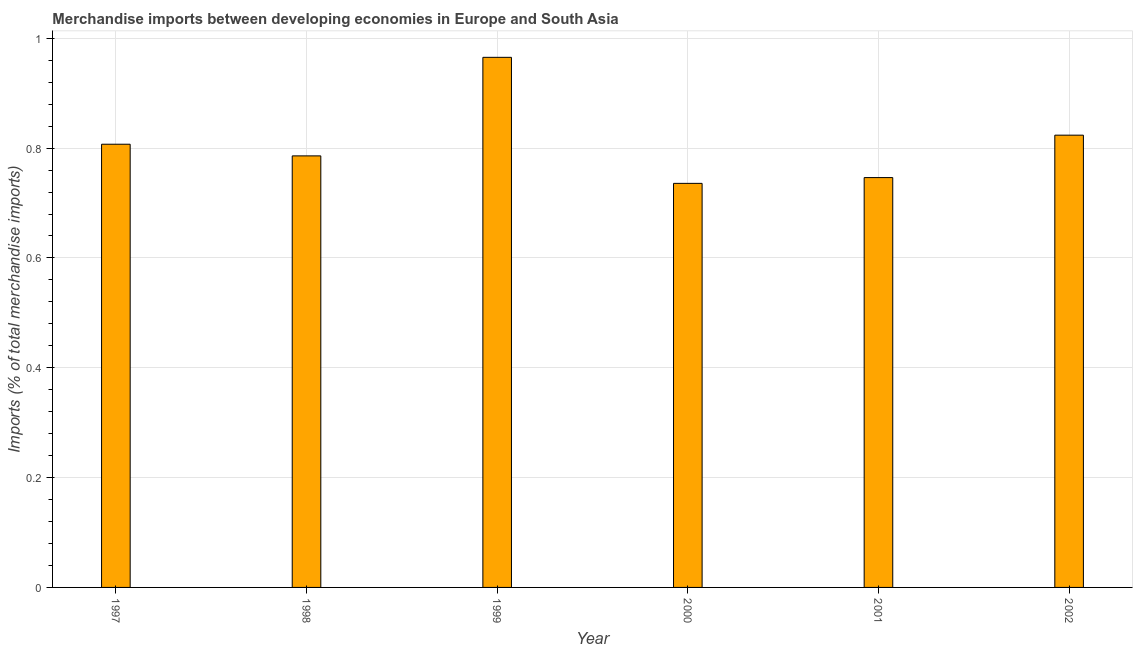Does the graph contain grids?
Your response must be concise. Yes. What is the title of the graph?
Your answer should be compact. Merchandise imports between developing economies in Europe and South Asia. What is the label or title of the Y-axis?
Provide a short and direct response. Imports (% of total merchandise imports). What is the merchandise imports in 2000?
Give a very brief answer. 0.74. Across all years, what is the maximum merchandise imports?
Make the answer very short. 0.97. Across all years, what is the minimum merchandise imports?
Your answer should be compact. 0.74. In which year was the merchandise imports maximum?
Offer a terse response. 1999. In which year was the merchandise imports minimum?
Ensure brevity in your answer.  2000. What is the sum of the merchandise imports?
Provide a short and direct response. 4.86. What is the difference between the merchandise imports in 2000 and 2001?
Offer a terse response. -0.01. What is the average merchandise imports per year?
Provide a succinct answer. 0.81. What is the median merchandise imports?
Your response must be concise. 0.8. In how many years, is the merchandise imports greater than 0.12 %?
Your response must be concise. 6. What is the ratio of the merchandise imports in 1998 to that in 1999?
Offer a terse response. 0.81. Is the merchandise imports in 1998 less than that in 1999?
Offer a very short reply. Yes. Is the difference between the merchandise imports in 2000 and 2002 greater than the difference between any two years?
Your answer should be very brief. No. What is the difference between the highest and the second highest merchandise imports?
Provide a short and direct response. 0.14. Is the sum of the merchandise imports in 2000 and 2001 greater than the maximum merchandise imports across all years?
Your answer should be very brief. Yes. What is the difference between the highest and the lowest merchandise imports?
Offer a terse response. 0.23. Are the values on the major ticks of Y-axis written in scientific E-notation?
Your answer should be compact. No. What is the Imports (% of total merchandise imports) in 1997?
Offer a terse response. 0.81. What is the Imports (% of total merchandise imports) in 1998?
Offer a very short reply. 0.79. What is the Imports (% of total merchandise imports) of 1999?
Give a very brief answer. 0.97. What is the Imports (% of total merchandise imports) of 2000?
Offer a very short reply. 0.74. What is the Imports (% of total merchandise imports) in 2001?
Your response must be concise. 0.75. What is the Imports (% of total merchandise imports) in 2002?
Give a very brief answer. 0.82. What is the difference between the Imports (% of total merchandise imports) in 1997 and 1998?
Offer a terse response. 0.02. What is the difference between the Imports (% of total merchandise imports) in 1997 and 1999?
Offer a very short reply. -0.16. What is the difference between the Imports (% of total merchandise imports) in 1997 and 2000?
Your response must be concise. 0.07. What is the difference between the Imports (% of total merchandise imports) in 1997 and 2001?
Ensure brevity in your answer.  0.06. What is the difference between the Imports (% of total merchandise imports) in 1997 and 2002?
Give a very brief answer. -0.02. What is the difference between the Imports (% of total merchandise imports) in 1998 and 1999?
Make the answer very short. -0.18. What is the difference between the Imports (% of total merchandise imports) in 1998 and 2000?
Make the answer very short. 0.05. What is the difference between the Imports (% of total merchandise imports) in 1998 and 2001?
Provide a short and direct response. 0.04. What is the difference between the Imports (% of total merchandise imports) in 1998 and 2002?
Provide a short and direct response. -0.04. What is the difference between the Imports (% of total merchandise imports) in 1999 and 2000?
Your answer should be very brief. 0.23. What is the difference between the Imports (% of total merchandise imports) in 1999 and 2001?
Your response must be concise. 0.22. What is the difference between the Imports (% of total merchandise imports) in 1999 and 2002?
Give a very brief answer. 0.14. What is the difference between the Imports (% of total merchandise imports) in 2000 and 2001?
Give a very brief answer. -0.01. What is the difference between the Imports (% of total merchandise imports) in 2000 and 2002?
Give a very brief answer. -0.09. What is the difference between the Imports (% of total merchandise imports) in 2001 and 2002?
Provide a short and direct response. -0.08. What is the ratio of the Imports (% of total merchandise imports) in 1997 to that in 1999?
Your response must be concise. 0.84. What is the ratio of the Imports (% of total merchandise imports) in 1997 to that in 2000?
Provide a short and direct response. 1.1. What is the ratio of the Imports (% of total merchandise imports) in 1997 to that in 2001?
Offer a terse response. 1.08. What is the ratio of the Imports (% of total merchandise imports) in 1997 to that in 2002?
Your response must be concise. 0.98. What is the ratio of the Imports (% of total merchandise imports) in 1998 to that in 1999?
Make the answer very short. 0.81. What is the ratio of the Imports (% of total merchandise imports) in 1998 to that in 2000?
Give a very brief answer. 1.07. What is the ratio of the Imports (% of total merchandise imports) in 1998 to that in 2001?
Offer a terse response. 1.05. What is the ratio of the Imports (% of total merchandise imports) in 1998 to that in 2002?
Your response must be concise. 0.95. What is the ratio of the Imports (% of total merchandise imports) in 1999 to that in 2000?
Give a very brief answer. 1.31. What is the ratio of the Imports (% of total merchandise imports) in 1999 to that in 2001?
Keep it short and to the point. 1.29. What is the ratio of the Imports (% of total merchandise imports) in 1999 to that in 2002?
Make the answer very short. 1.17. What is the ratio of the Imports (% of total merchandise imports) in 2000 to that in 2001?
Provide a short and direct response. 0.99. What is the ratio of the Imports (% of total merchandise imports) in 2000 to that in 2002?
Offer a very short reply. 0.89. What is the ratio of the Imports (% of total merchandise imports) in 2001 to that in 2002?
Give a very brief answer. 0.91. 